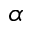<formula> <loc_0><loc_0><loc_500><loc_500>\alpha</formula> 